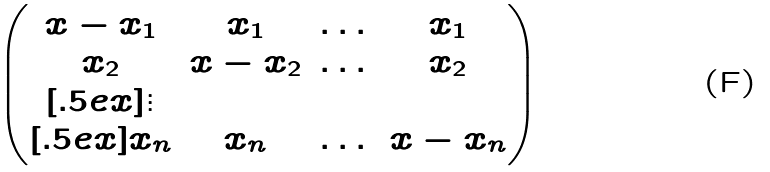Convert formula to latex. <formula><loc_0><loc_0><loc_500><loc_500>\begin{pmatrix} x - x _ { 1 } & x _ { 1 } & \dots & x _ { 1 } \\ x _ { 2 } & x - x _ { 2 } & \dots & x _ { 2 } \\ [ . 5 e x ] \vdots \\ [ . 5 e x ] x _ { n } & x _ { n } & \dots & x - x _ { n } \end{pmatrix}</formula> 